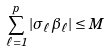Convert formula to latex. <formula><loc_0><loc_0><loc_500><loc_500>\sum _ { \ell = 1 } ^ { p } | \sigma _ { \ell } \beta _ { \ell } | \leq { M }</formula> 